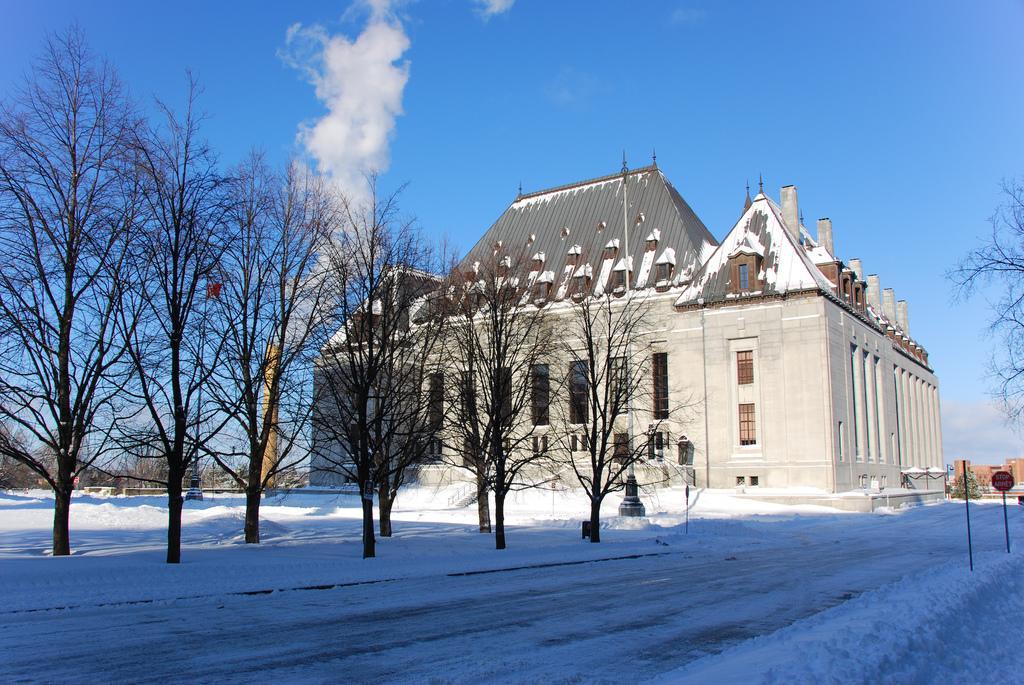Describe this image in one or two sentences. In the picture I can see road covered with snow, I can see dry trees, stone building, tower, smoke, boards and the blue color sky with clouds in the background. 